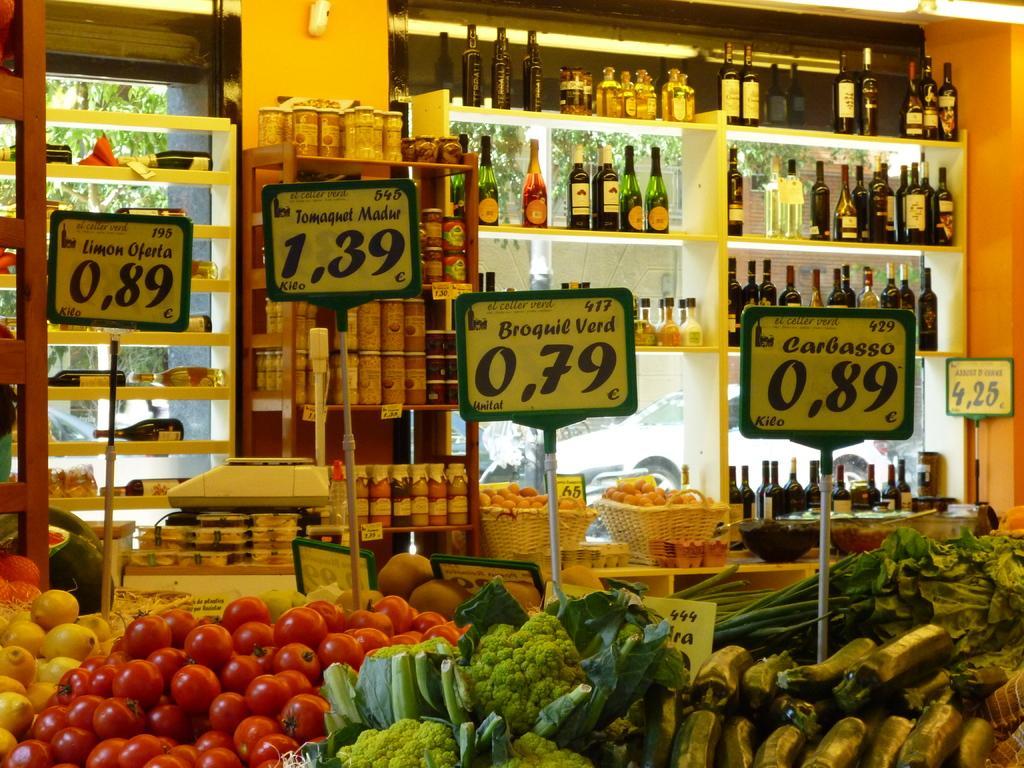Describe this image in one or two sentences. In this picture, there are vegetables like tomatoes, cauliflowers, brinjals, leafy vegetables, etc are placed at the bottom. In the center, there are boards with some texts. On the top, there are cracks filled with bottles and jars. 